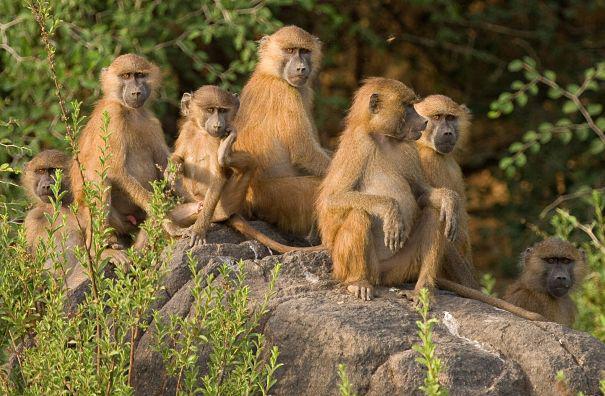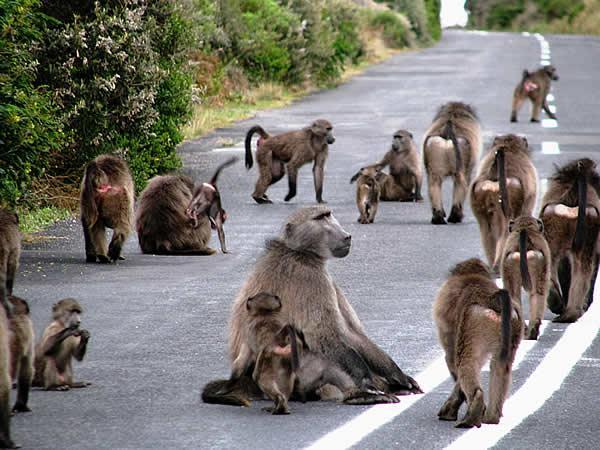The first image is the image on the left, the second image is the image on the right. Given the left and right images, does the statement "There are no more than four monkeys in the image on the left." hold true? Answer yes or no. No. 